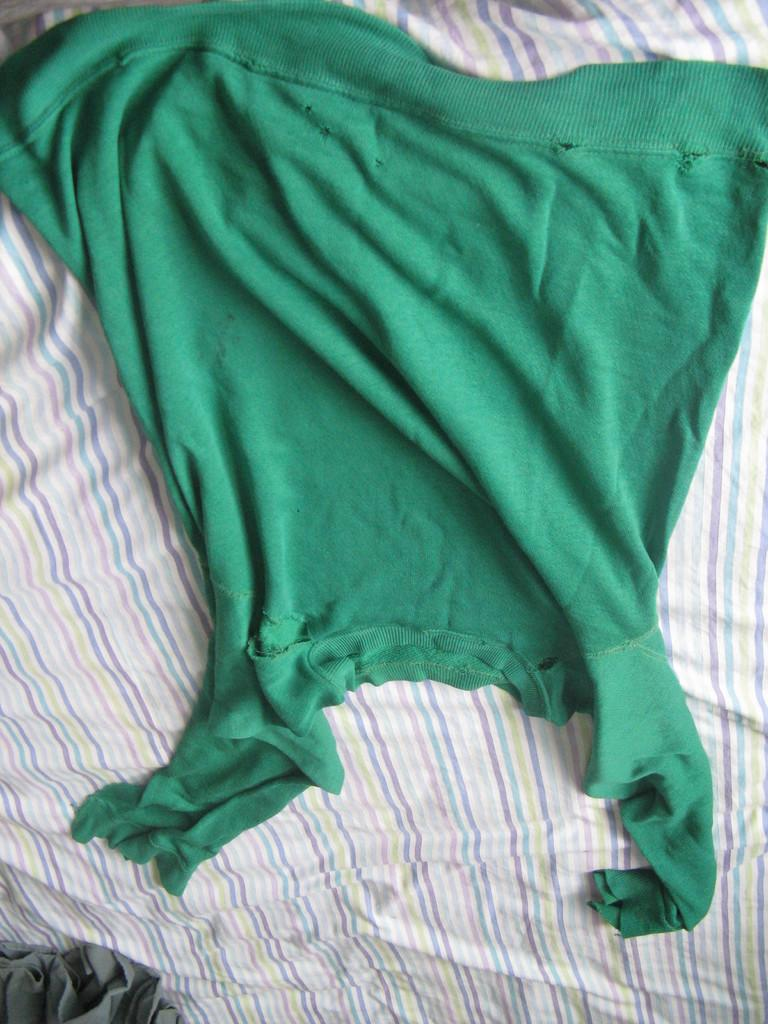What is the main object in the image? There is a cloth in the image. Where is the cloth located? The cloth is on a bed sheet. What type of wing is visible on the cloth in the image? There is no wing visible on the cloth in the image. What appliance is being covered by the cloth in the image? There is no appliance present in the image; it only features a cloth on a bed sheet. 